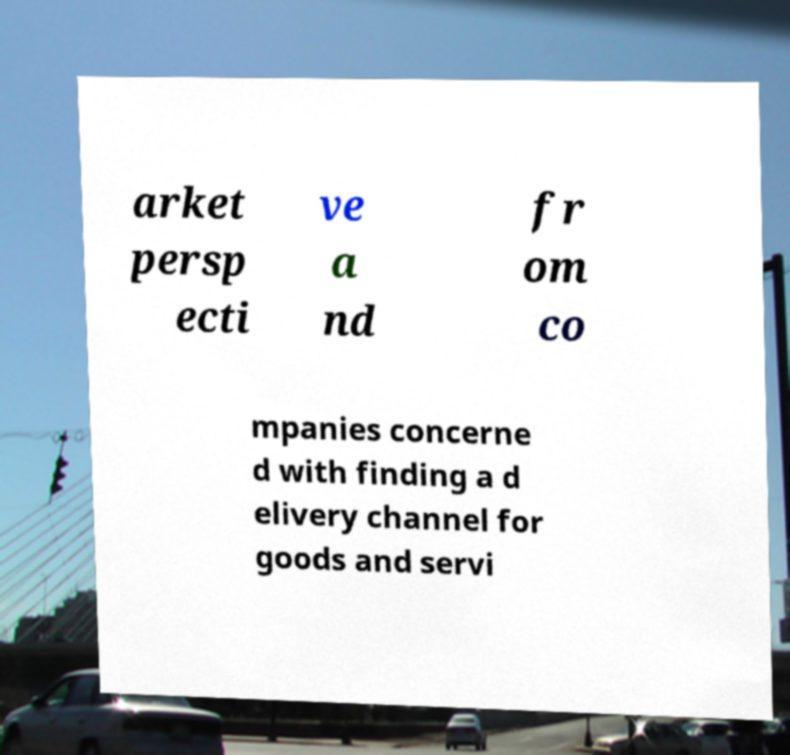I need the written content from this picture converted into text. Can you do that? arket persp ecti ve a nd fr om co mpanies concerne d with finding a d elivery channel for goods and servi 